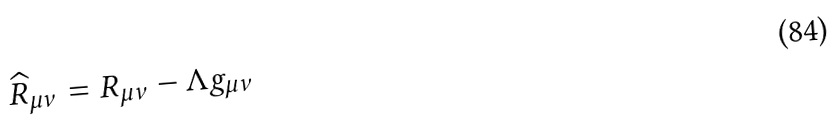Convert formula to latex. <formula><loc_0><loc_0><loc_500><loc_500>\widehat { R } _ { \mu \nu } = R _ { \mu \nu } - \Lambda g _ { \mu \nu }</formula> 